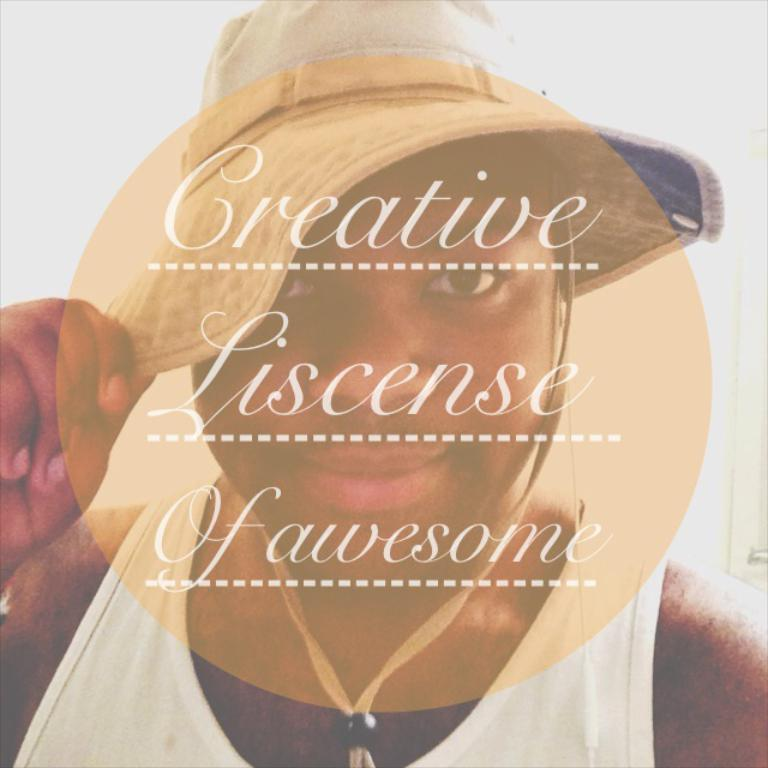Who is the main subject in the picture? There is a lady in the picture. What is the lady wearing on her head? The lady is wearing a cap. Is there any text or design on the cap? Yes, there is text on the cap. What type of alarm is the lady holding in the picture? There is no alarm present in the picture; the lady is wearing a cap with text on it. 